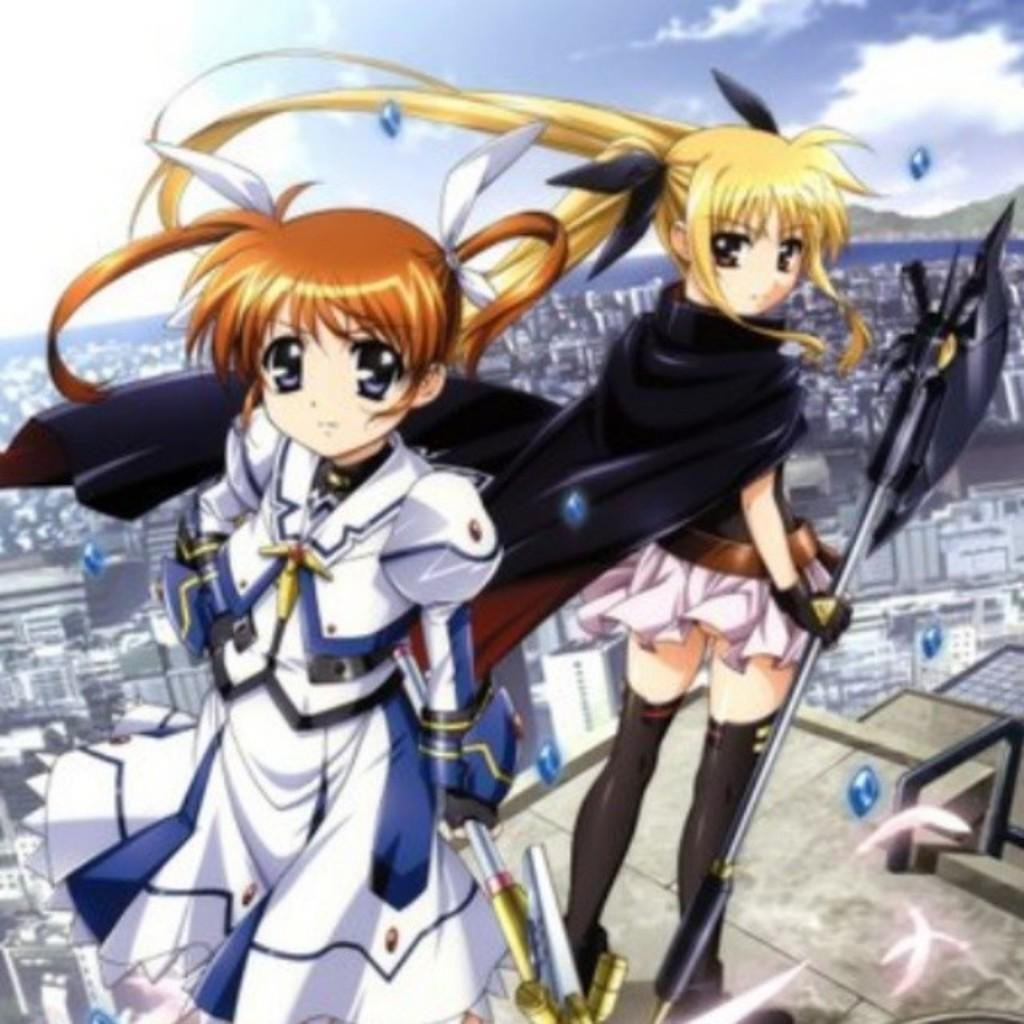Who or what can be seen in the image? There are two cartoon characters in the image. What can be seen in the background of the image? There are buildings and the sky visible in the background of the image. What type of brick is being used to build the division between the cartoon characters? There is no brick or division between the cartoon characters in the image. Can you tell me how many dogs are present in the image? There are no dogs present in the image; it features two cartoon characters and a background with buildings and the sky. 